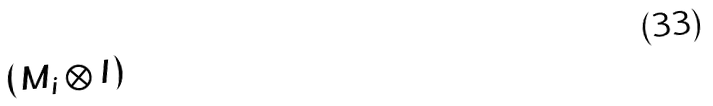<formula> <loc_0><loc_0><loc_500><loc_500>( M _ { i } \otimes I )</formula> 